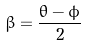<formula> <loc_0><loc_0><loc_500><loc_500>\beta = \frac { \theta - \phi } { 2 }</formula> 